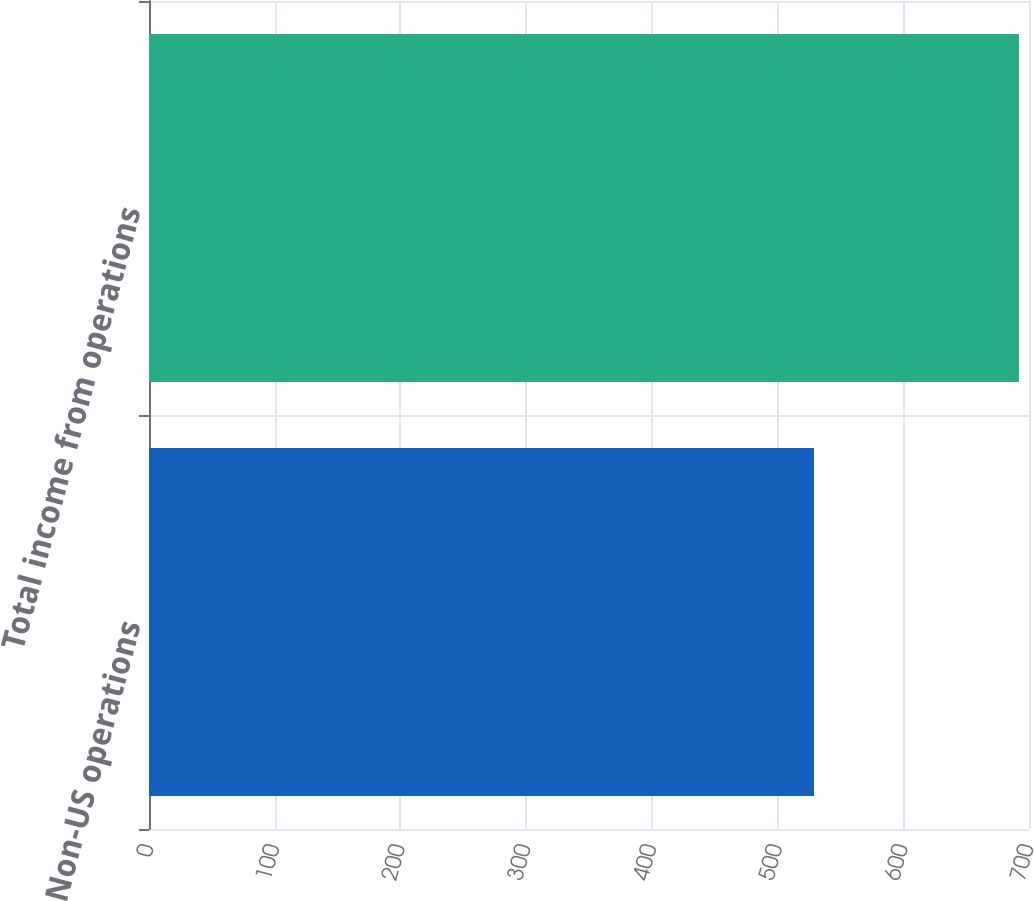<chart> <loc_0><loc_0><loc_500><loc_500><bar_chart><fcel>Non-US operations<fcel>Total income from operations<nl><fcel>529<fcel>692<nl></chart> 